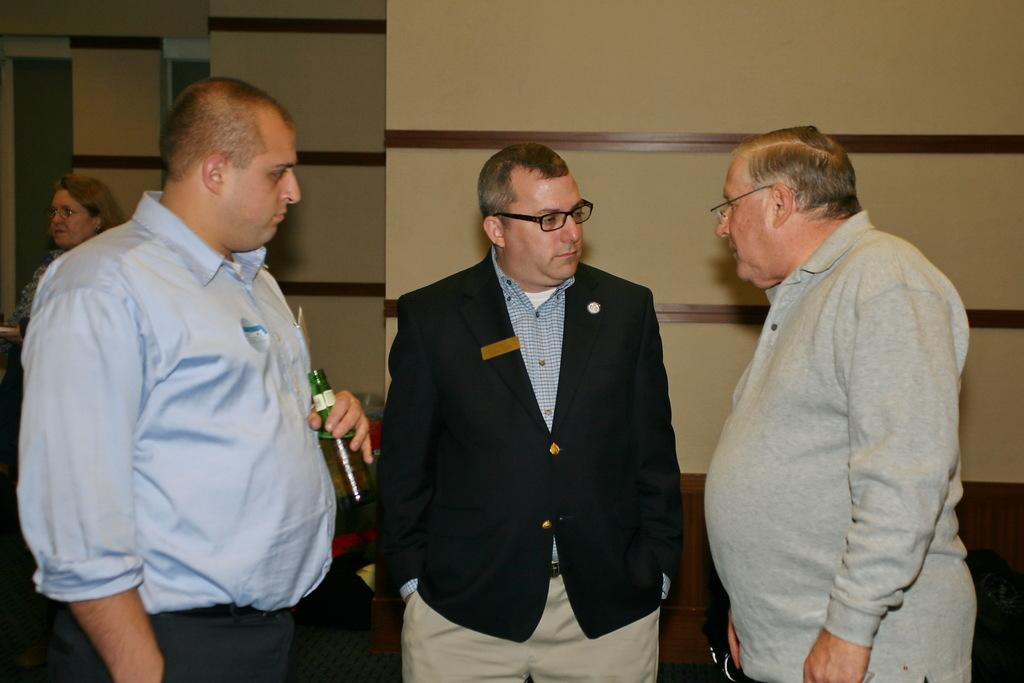How many people are in the image? There are three persons standing in the center of the image. What can be seen in the background of the image? There is a wall in the background of the image. What type of finger can be seen holding a truck in the image? There is no finger or truck present in the image. How can the persons in the image measure the distance between them? The image does not provide any information about measuring distances between the persons. 